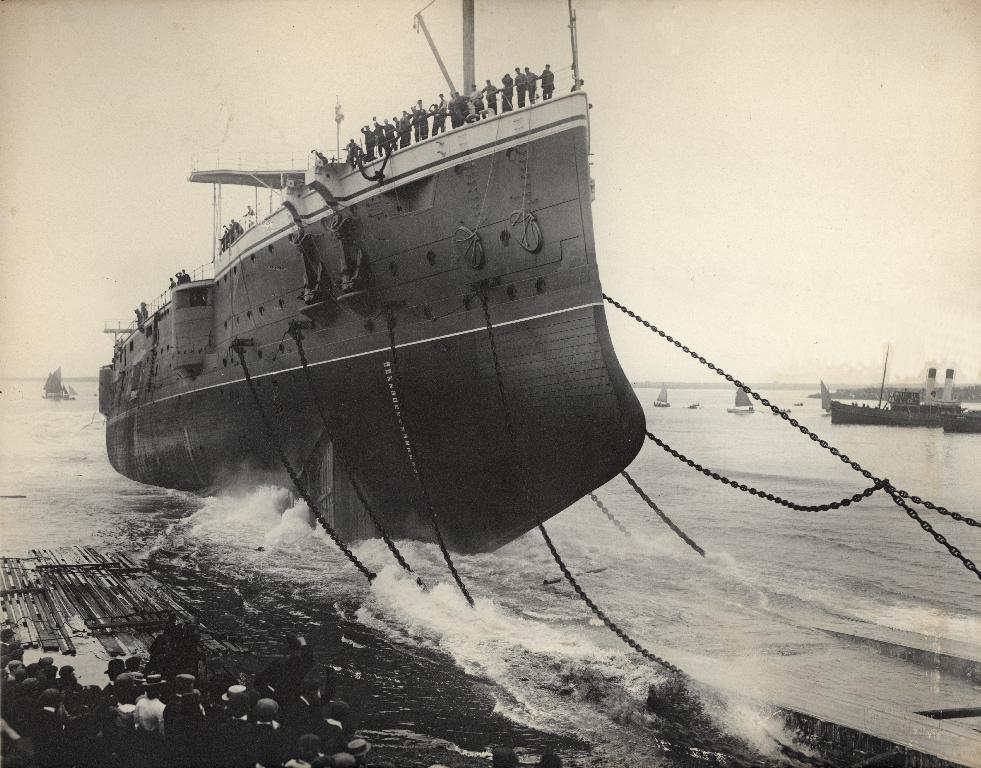What type of vehicles are in the image? There are boats in the image. What is the primary element surrounding the boats? There is water visible in the image. Can you describe the people in the image? There are people in the image. What is visible at the top of the image? The sky is visible at the top of the image. What type of oil can be seen floating on the water in the image? There is no oil visible in the image; only boats, water, people, and the sky are present. 